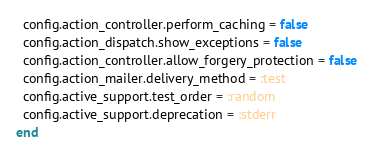<code> <loc_0><loc_0><loc_500><loc_500><_Ruby_>  config.action_controller.perform_caching = false
  config.action_dispatch.show_exceptions = false
  config.action_controller.allow_forgery_protection = false
  config.action_mailer.delivery_method = :test
  config.active_support.test_order = :random
  config.active_support.deprecation = :stderr
end
</code> 